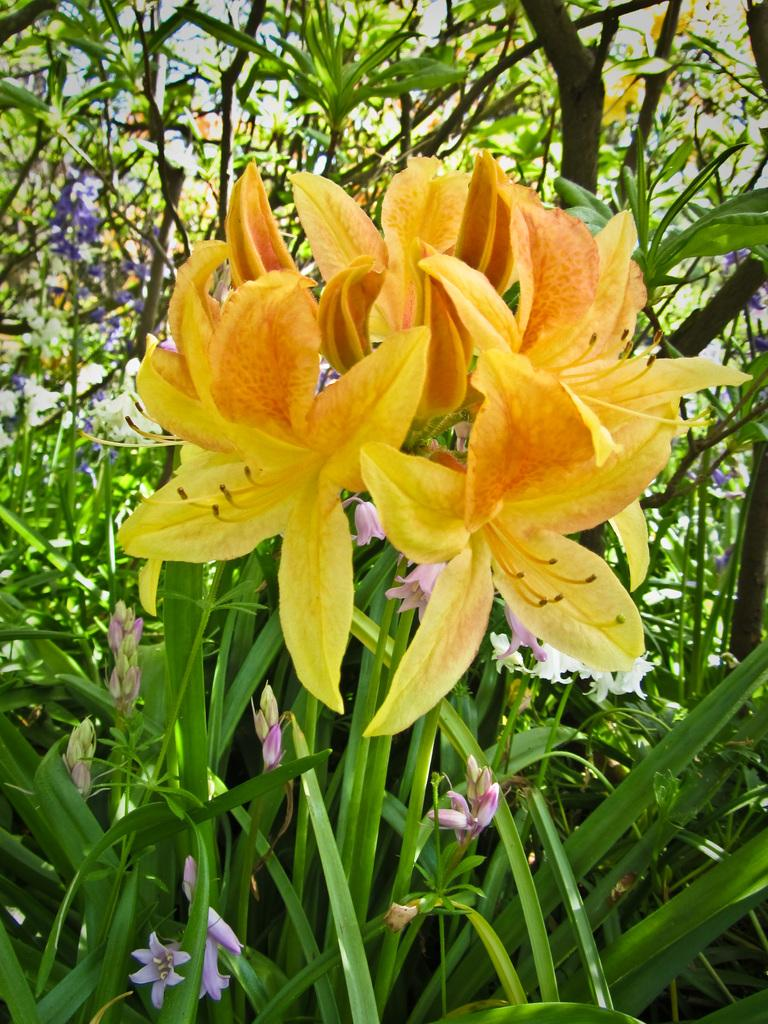What type of plants can be seen in the image? There are plants with flowers in the image. What can be seen in the background of the image? The sky is visible in the background of the image. What type of tooth is visible in the image? There are no teeth present in the image; it features plants with flowers and the sky. What type of voice can be heard coming from the plants in the image? Plants do not have the ability to produce or emit voices, so there is no voice present in the image. 